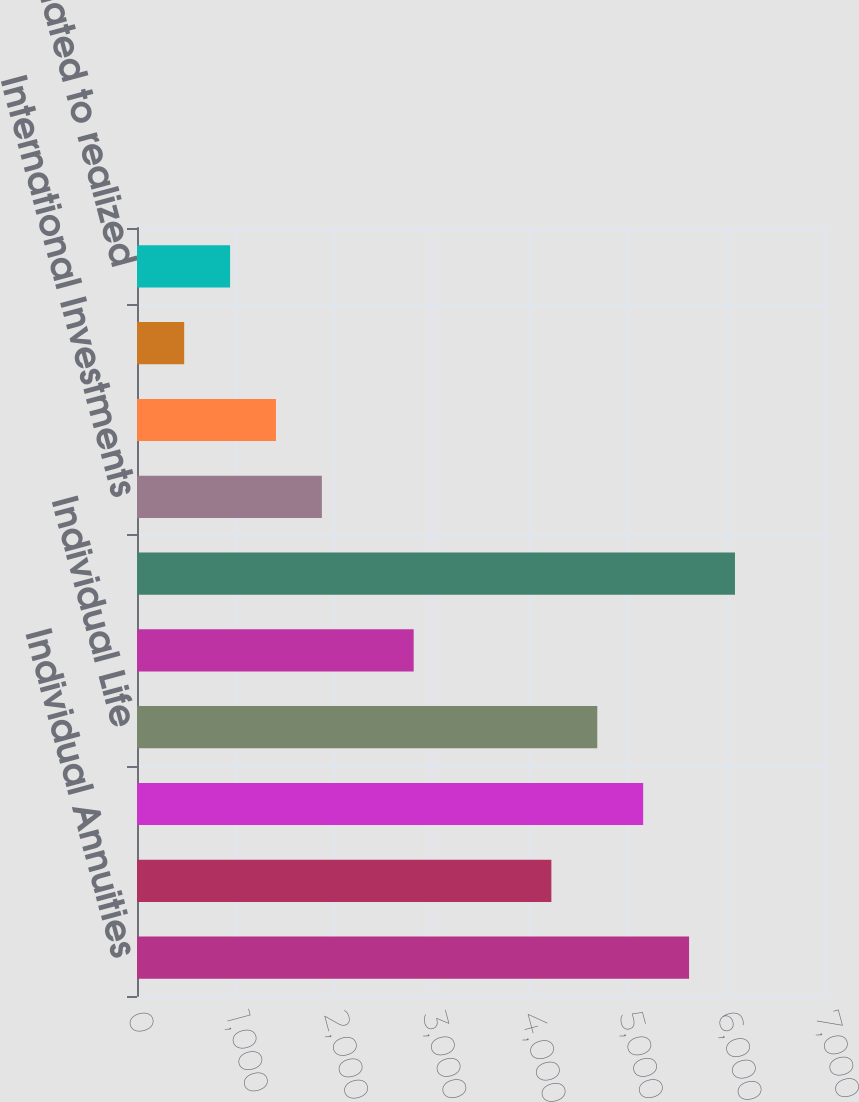Convert chart to OTSL. <chart><loc_0><loc_0><loc_500><loc_500><bar_chart><fcel>Individual Annuities<fcel>Retirement<fcel>Asset Management<fcel>Individual Life<fcel>Group Insurance<fcel>International Insurance<fcel>International Investments<fcel>Corporate and Other<fcel>Realized investment gains<fcel>Charges related to realized<nl><fcel>5617<fcel>4216<fcel>5150<fcel>4683<fcel>2815<fcel>6084<fcel>1881<fcel>1414<fcel>480<fcel>947<nl></chart> 